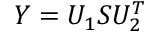Convert formula to latex. <formula><loc_0><loc_0><loc_500><loc_500>Y = U _ { 1 } S U _ { 2 } ^ { T }</formula> 